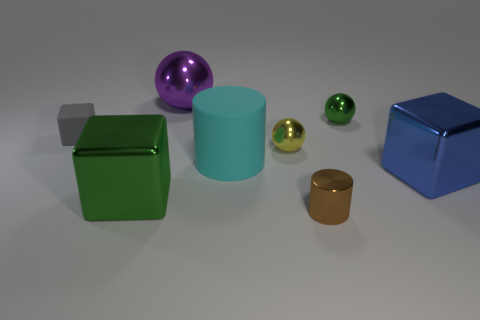There is a block that is in front of the blue object that is on the right side of the small gray object; how many big metal cubes are to the right of it?
Ensure brevity in your answer.  1. Is the number of rubber things that are behind the small yellow metallic thing greater than the number of yellow balls that are behind the tiny rubber thing?
Keep it short and to the point. Yes. What number of other small metal things are the same shape as the small green metallic object?
Provide a short and direct response. 1. How many things are objects on the left side of the large purple ball or big cubes to the left of the big purple shiny thing?
Provide a succinct answer. 2. The green object right of the small thing in front of the large cube that is right of the purple thing is made of what material?
Your answer should be compact. Metal. What material is the object that is to the right of the small brown metallic cylinder and in front of the green metal sphere?
Offer a terse response. Metal. Is there a cylinder that has the same size as the blue thing?
Your answer should be very brief. Yes. What number of purple balls are there?
Your response must be concise. 1. What number of small things are to the left of the big cyan matte thing?
Your answer should be very brief. 1. Is the tiny gray thing made of the same material as the brown thing?
Ensure brevity in your answer.  No. 